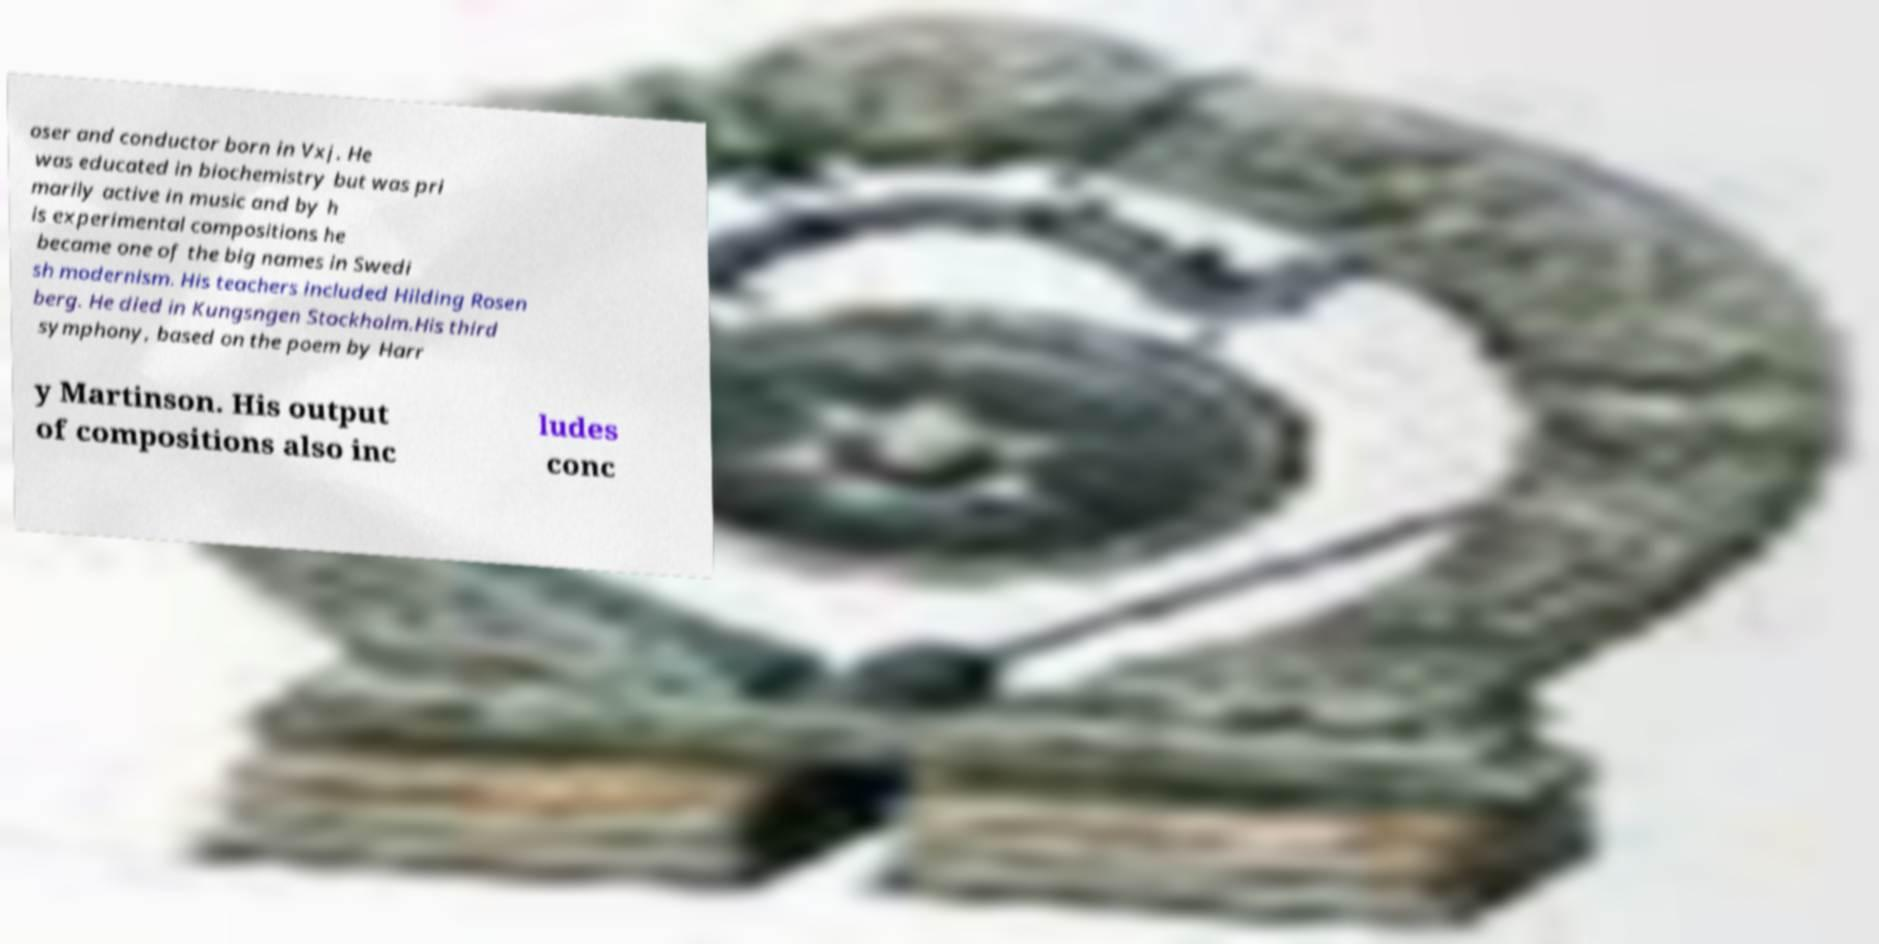There's text embedded in this image that I need extracted. Can you transcribe it verbatim? oser and conductor born in Vxj. He was educated in biochemistry but was pri marily active in music and by h is experimental compositions he became one of the big names in Swedi sh modernism. His teachers included Hilding Rosen berg. He died in Kungsngen Stockholm.His third symphony, based on the poem by Harr y Martinson. His output of compositions also inc ludes conc 